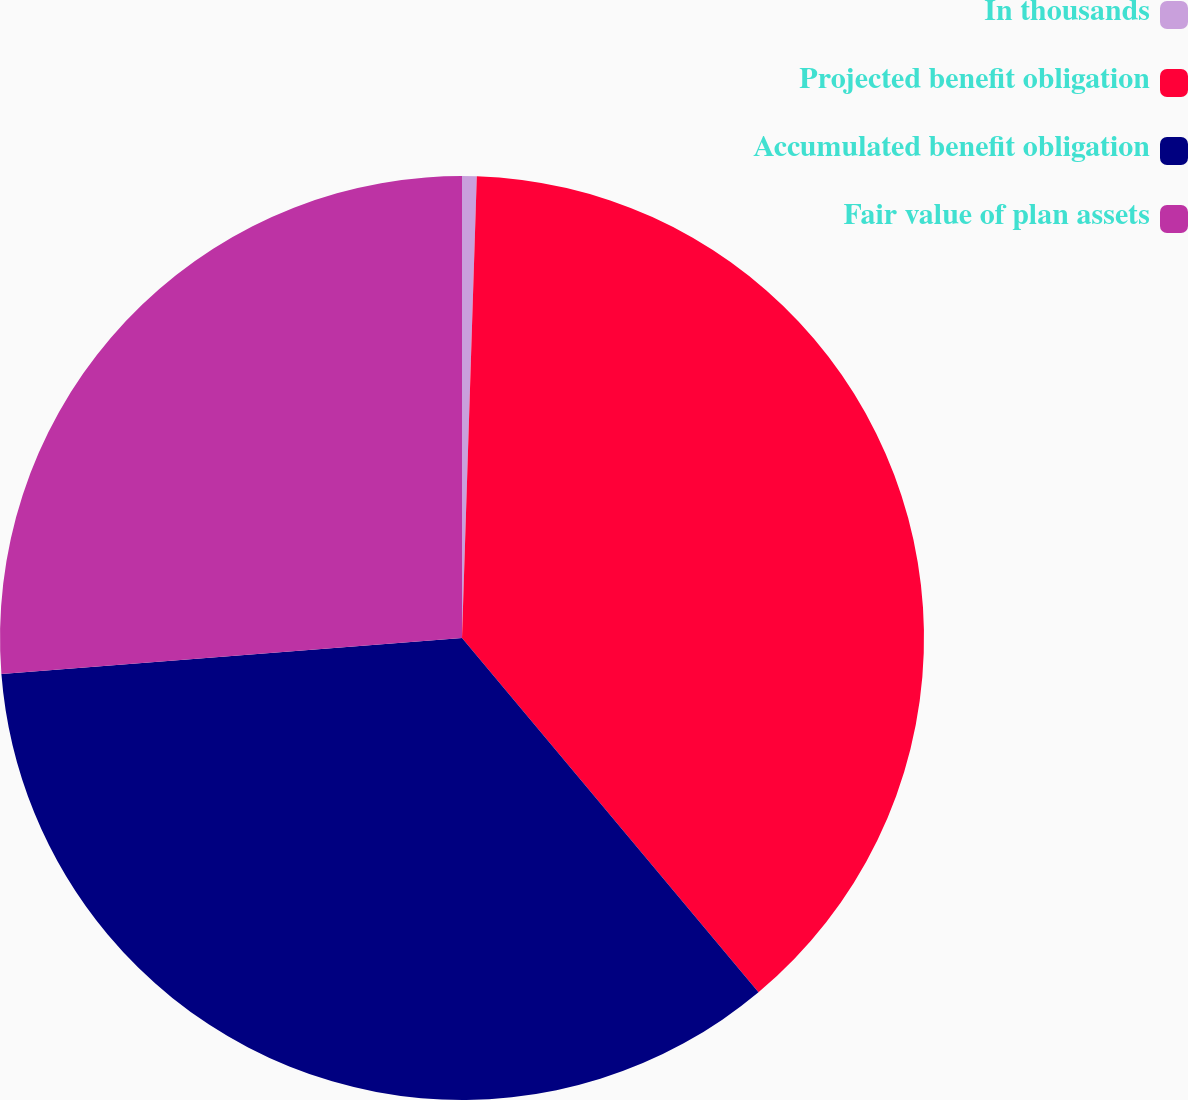Convert chart to OTSL. <chart><loc_0><loc_0><loc_500><loc_500><pie_chart><fcel>In thousands<fcel>Projected benefit obligation<fcel>Accumulated benefit obligation<fcel>Fair value of plan assets<nl><fcel>0.51%<fcel>38.4%<fcel>34.85%<fcel>26.24%<nl></chart> 